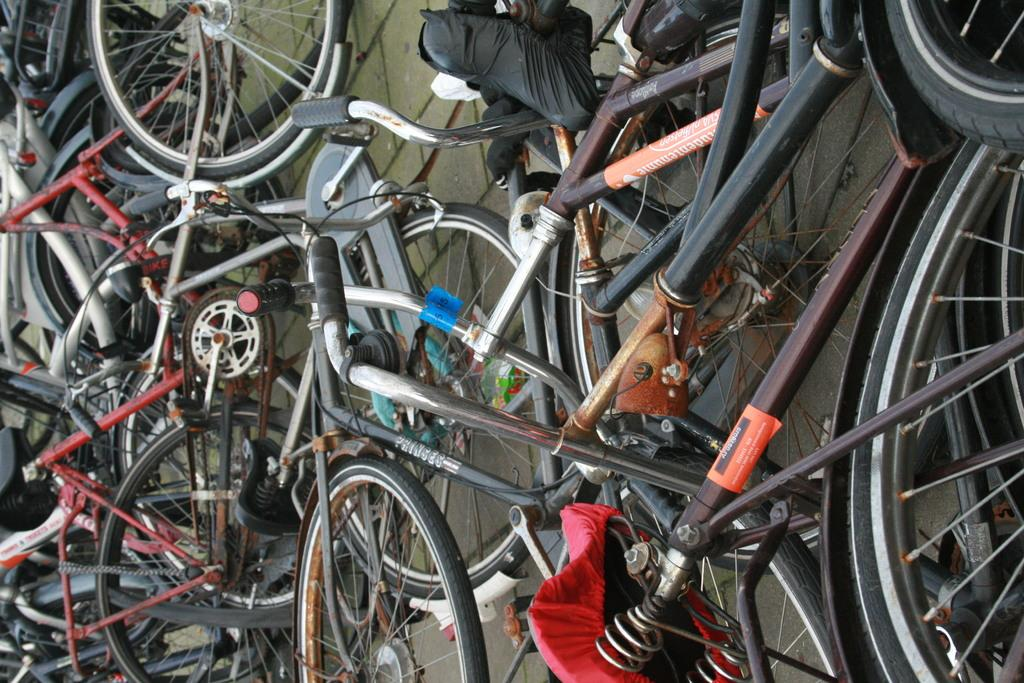What is the main subject of the image? The main subject of the image is a group of bicycles. Where are the bicycles located in the image? The bicycles are on the ground in the image. What type of boundary can be seen in the image? There is no boundary visible in the image; it only features a group of bicycles on the ground. Can you hear a fireman speaking in the image? There is no audio in the image, and no fireman is present, so it is not possible to hear a fireman speaking. 